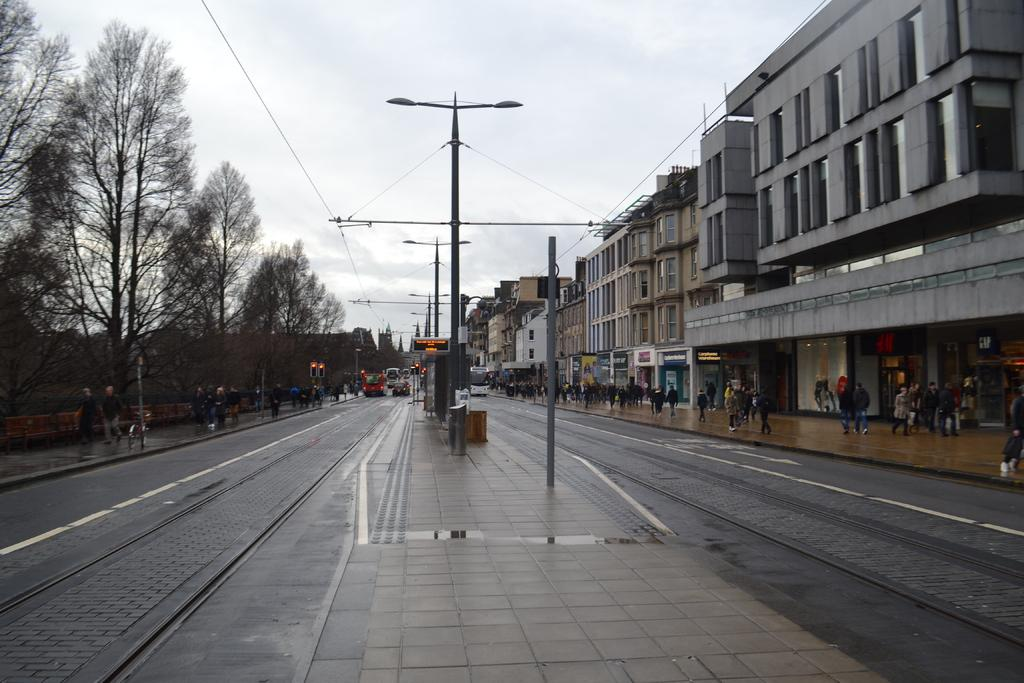What is the main feature of the image? There is a road in the image. What else can be seen along the road? There are poles, vehicles, people standing on the sidewalk, trees, and buildings in the image. What is visible in the background of the image? The sky is visible in the background of the image. What type of juice can be seen being shared by friends on the sidewalk in the image? There is no juice or friends present in the image; it only shows a road, poles, vehicles, people standing on the sidewalk, trees, buildings, and the sky. 